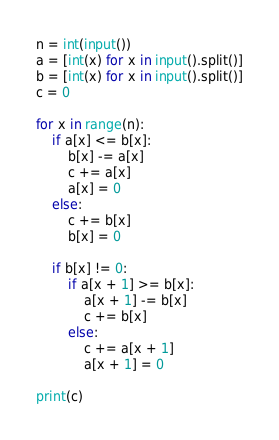Convert code to text. <code><loc_0><loc_0><loc_500><loc_500><_Python_>n = int(input())
a = [int(x) for x in input().split()]
b = [int(x) for x in input().split()]
c = 0

for x in range(n):
    if a[x] <= b[x]:
        b[x] -= a[x]
        c += a[x]
        a[x] = 0
    else:
        c += b[x]
        b[x] = 0

    if b[x] != 0:
        if a[x + 1] >= b[x]:
            a[x + 1] -= b[x]
            c += b[x]
        else:
            c += a[x + 1]
            a[x + 1] = 0

print(c)</code> 